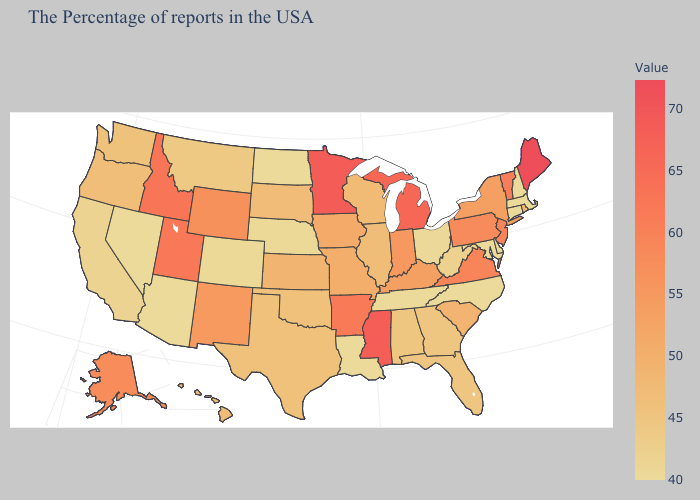Among the states that border California , does Arizona have the highest value?
Answer briefly. No. Among the states that border Nebraska , which have the highest value?
Be succinct. Wyoming. Is the legend a continuous bar?
Write a very short answer. Yes. Is the legend a continuous bar?
Concise answer only. Yes. Does South Carolina have the highest value in the South?
Short answer required. No. Among the states that border Kentucky , does Virginia have the highest value?
Keep it brief. Yes. Does Minnesota have the highest value in the MidWest?
Answer briefly. Yes. 